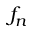Convert formula to latex. <formula><loc_0><loc_0><loc_500><loc_500>f _ { n }</formula> 